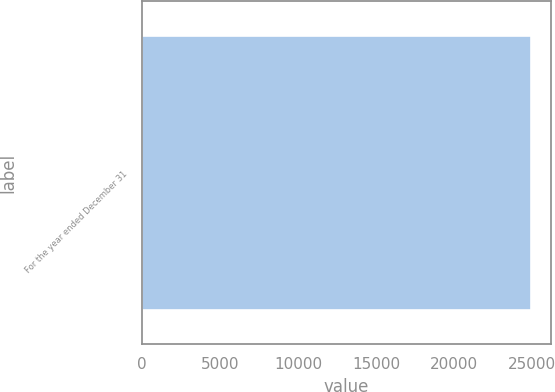Convert chart to OTSL. <chart><loc_0><loc_0><loc_500><loc_500><bar_chart><fcel>For the year ended December 31<nl><fcel>24939.5<nl></chart> 